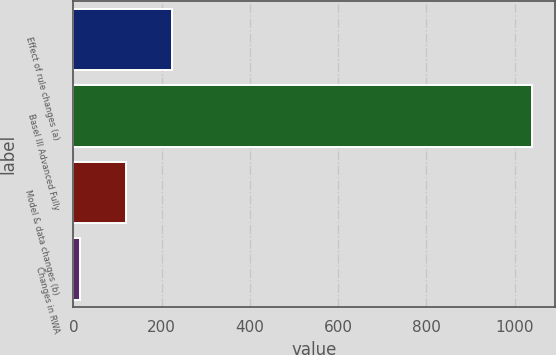Convert chart. <chart><loc_0><loc_0><loc_500><loc_500><bar_chart><fcel>Effect of rule changes (a)<fcel>Basel III Advanced Fully<fcel>Model & data changes (b)<fcel>Changes in RWA<nl><fcel>223<fcel>1040<fcel>119<fcel>15<nl></chart> 